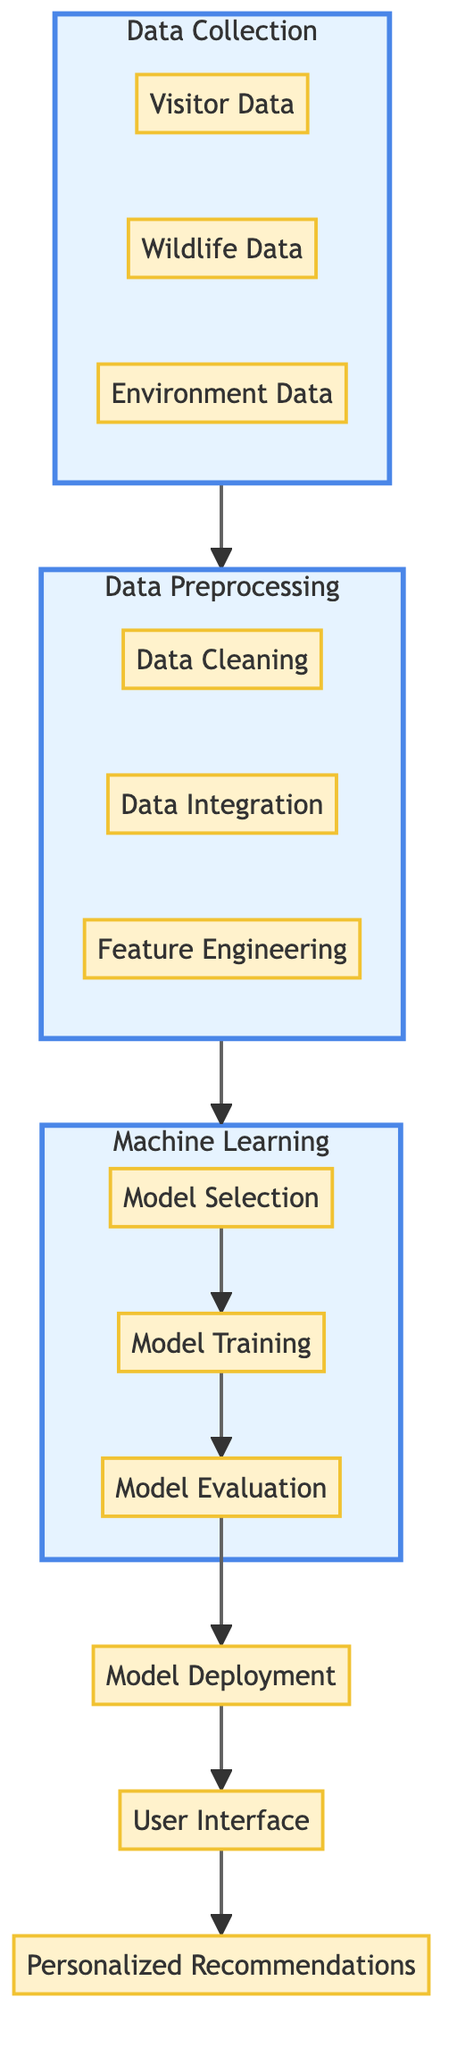What are the three types of data collected? The diagram shows three data types: Visitor Data, Wildlife Data, and Environment Data under the Data Collection subgraph.
Answer: Visitor Data, Wildlife Data, Environment Data How many nodes are in the Data Preprocessing section? In the Data Preprocessing section, there are three nodes: Data Cleaning, Data Integration, and Feature Engineering.
Answer: 3 What is the output of the Model Evaluation step? The Model Evaluation step does not have a direct output shown, but it connects to Model Deployment, indicating that it evaluates the model before it is deployed.
Answer: None What is the relationship between Data Collection and Data Preprocessing? The arrow from Data Collection to Data Preprocessing indicates that Data Collection feeds into Data Preprocessing, meaning that the collected data is used in the preprocessing phase.
Answer: Collects to Preprocess Which node comes before the User Interface in the flow? The User Interface node follows Model Deployment, so the node that comes directly before it in the flow is Model Deployment.
Answer: Model Deployment How many distinct subgraphs are present in the diagram? The diagram features three distinct subgraphs: Data Collection, Data Preprocessing, and Machine Learning.
Answer: 3 What is the final output of the diagram sequence? The final output of the diagram sequence is Personalized Recommendations, which is the endpoint of the flow connected to the User Interface.
Answer: Personalized Recommendations Identify the step that involves improving the model's performance. The step that involves improving the model's performance is Model Training, where the selected model is trained using the preprocessed data to enhance its ability to make predictions.
Answer: Model Training Which step directly follows Model Selection? After Model Selection, the next step in the flowchart is Model Training, where the selected model is then trained.
Answer: Model Training 